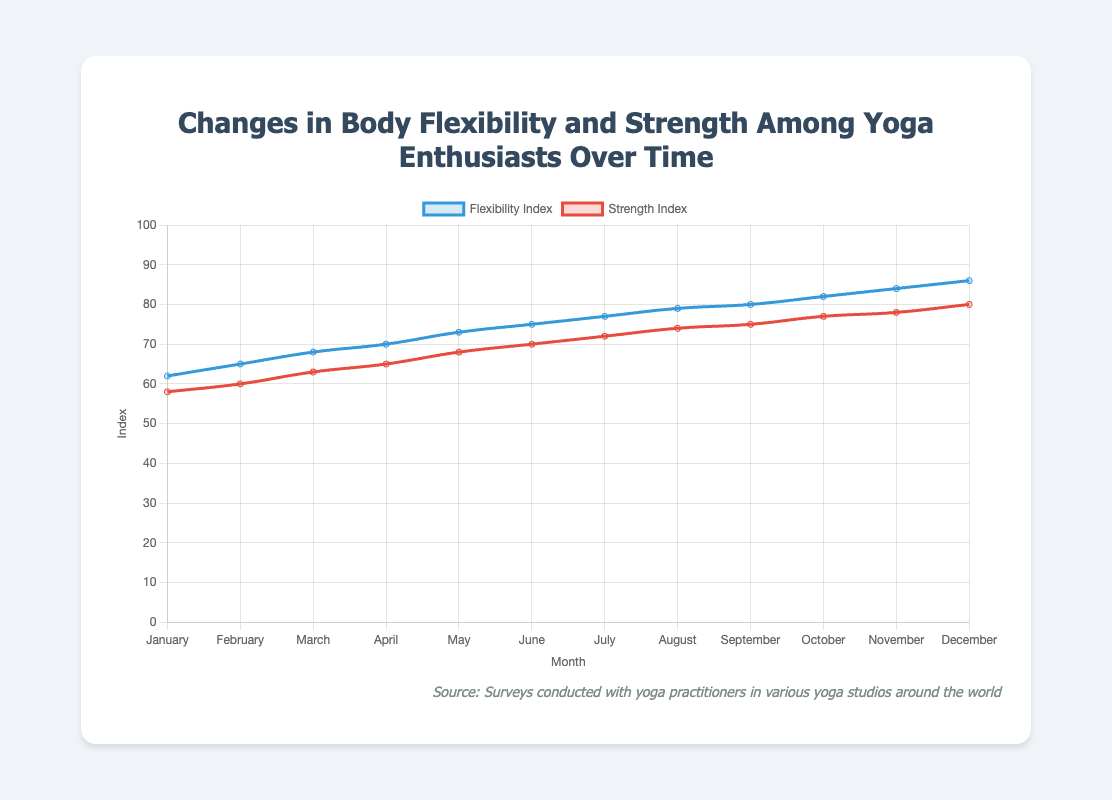What is the difference in the Flexibility Index between January and July? To find the difference, subtract the index value in January (62) from the index value in July (77). 77 - 62 = 15.
Answer: 15 Between which months does the Strength Index increase the most? By examining the chart, the largest increase is between June and July, where the Strength Index increases from 70 to 72, a difference of 2.
Answer: June to July Does the Flexibility Index increase at a constant rate? Observing the line trend in the chart, the Flexibility Index generally shows a consistent upward trend month by month, without sudden spikes or drops.
Answer: Yes What is the average Strength Index for the months January to June? Add the Strength Index values from January to June and divide by the number of months. (58 + 60 + 63 + 65 + 68 + 70) / 6 = 384 / 6 = 64.
Answer: 64 How does the visual representation of the Flexibility Index compare to the Strength Index? The Flexibility Index is represented by a blue line and the Strength Index by a red line. Both lines show an upward trend, but the Flexibility Index line is generally higher throughout the year.
Answer: The Flexibility Index is higher and follows a similar upward trend compared to the Strength Index Which month shows the smallest gap between the Flexibility and Strength indices? Observing the chart, the smallest gap is in May, where the gap is 73 - 68 = 5.
Answer: May What is the median value of the Flexibility Index over the year? To find the median, list the Flexibility Index values in order and find the middle value. Since there are 12 values, the median is the average of the 6th and 7th values. (75 + 77) / 2 = 76.
Answer: 76 By how much does the Strength Index increase from March to December? Subtract the Strength Index value in March (63) from the value in December (80). 80 - 63 = 17.
Answer: 17 